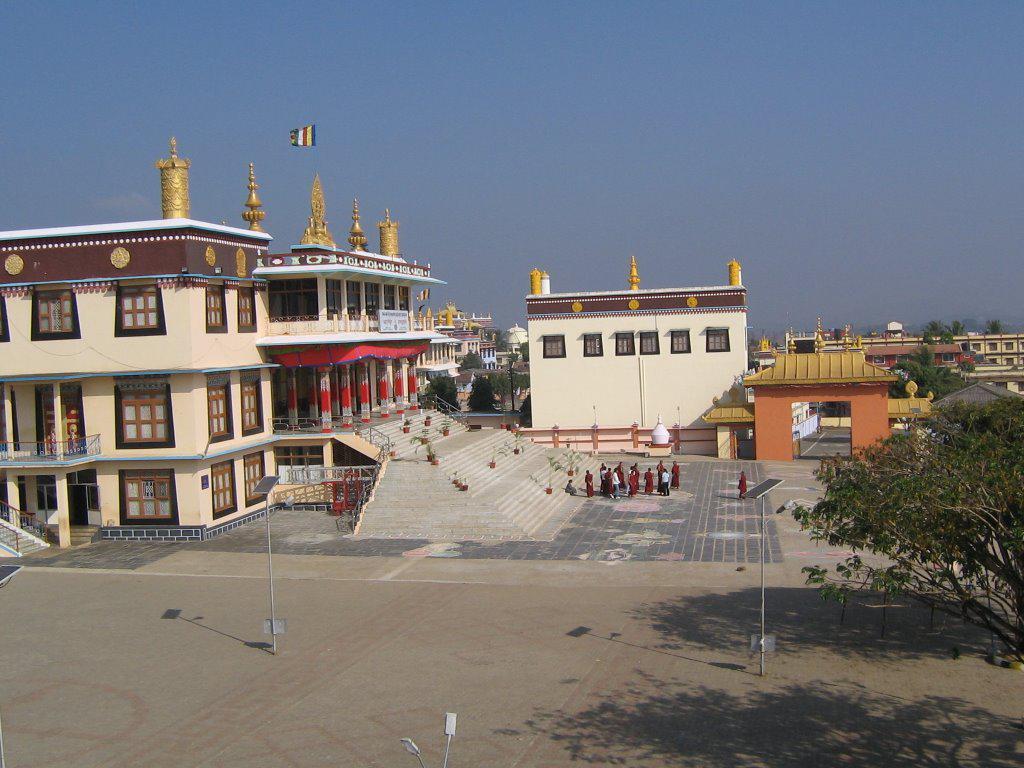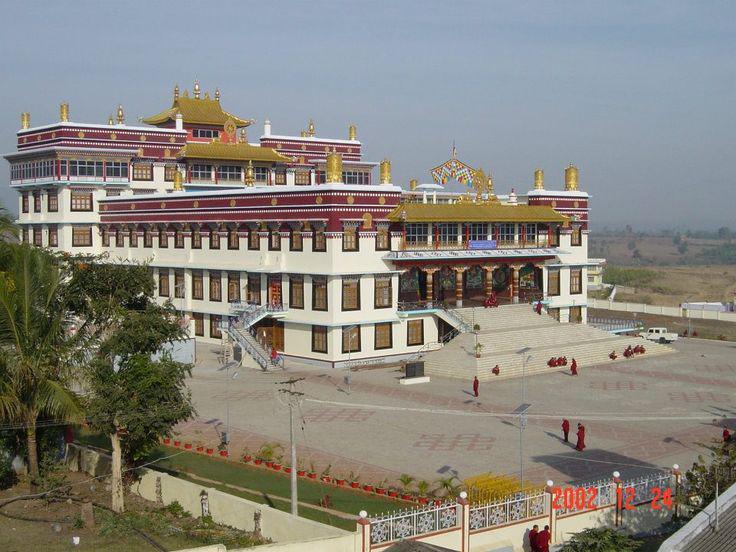The first image is the image on the left, the second image is the image on the right. Analyze the images presented: Is the assertion "There is an empty parking lot in front of a building in at least one of the images." valid? Answer yes or no. Yes. The first image is the image on the left, the second image is the image on the right. Analyze the images presented: Is the assertion "Left image includes a steep foliage-covered slope and a blue cloud-scattered sky in the scene with a building led to by a stairway." valid? Answer yes or no. No. 